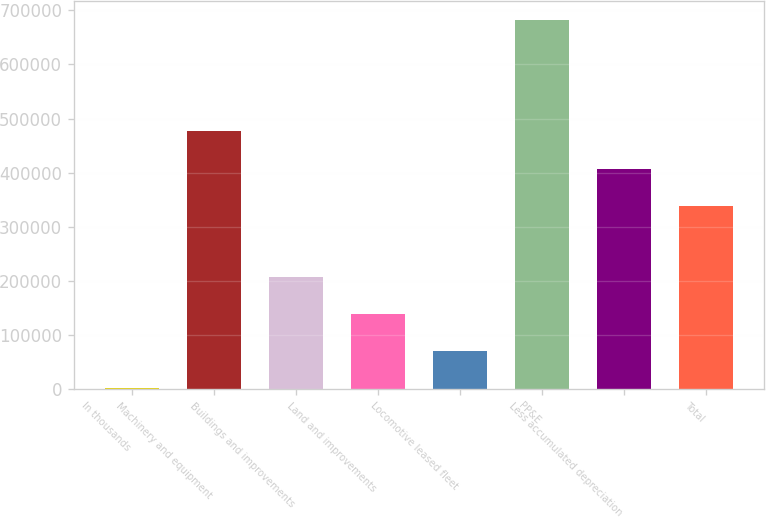Convert chart. <chart><loc_0><loc_0><loc_500><loc_500><bar_chart><fcel>In thousands<fcel>Machinery and equipment<fcel>Buildings and improvements<fcel>Land and improvements<fcel>Locomotive leased fleet<fcel>PP&E<fcel>Less accumulated depreciation<fcel>Total<nl><fcel>2014<fcel>476467<fcel>206320<fcel>138218<fcel>70116<fcel>683034<fcel>407213<fcel>339111<nl></chart> 